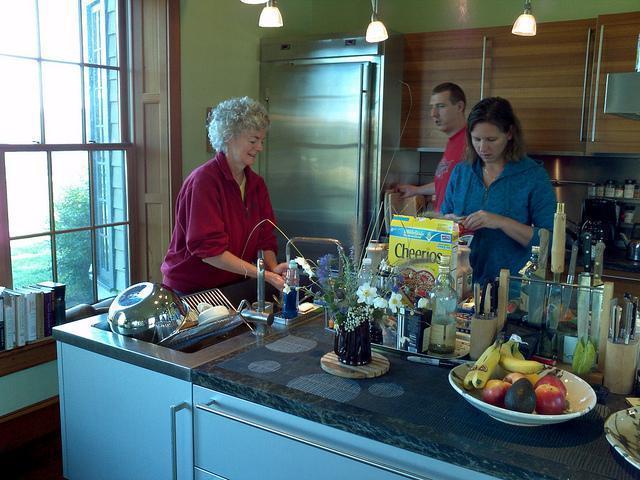What time of day is it?
Choose the correct response and explain in the format: 'Answer: answer
Rationale: rationale.'
Options: Night, evening, morning, afternoon. Answer: morning.
Rationale: They have cereal and other breakfast items out 